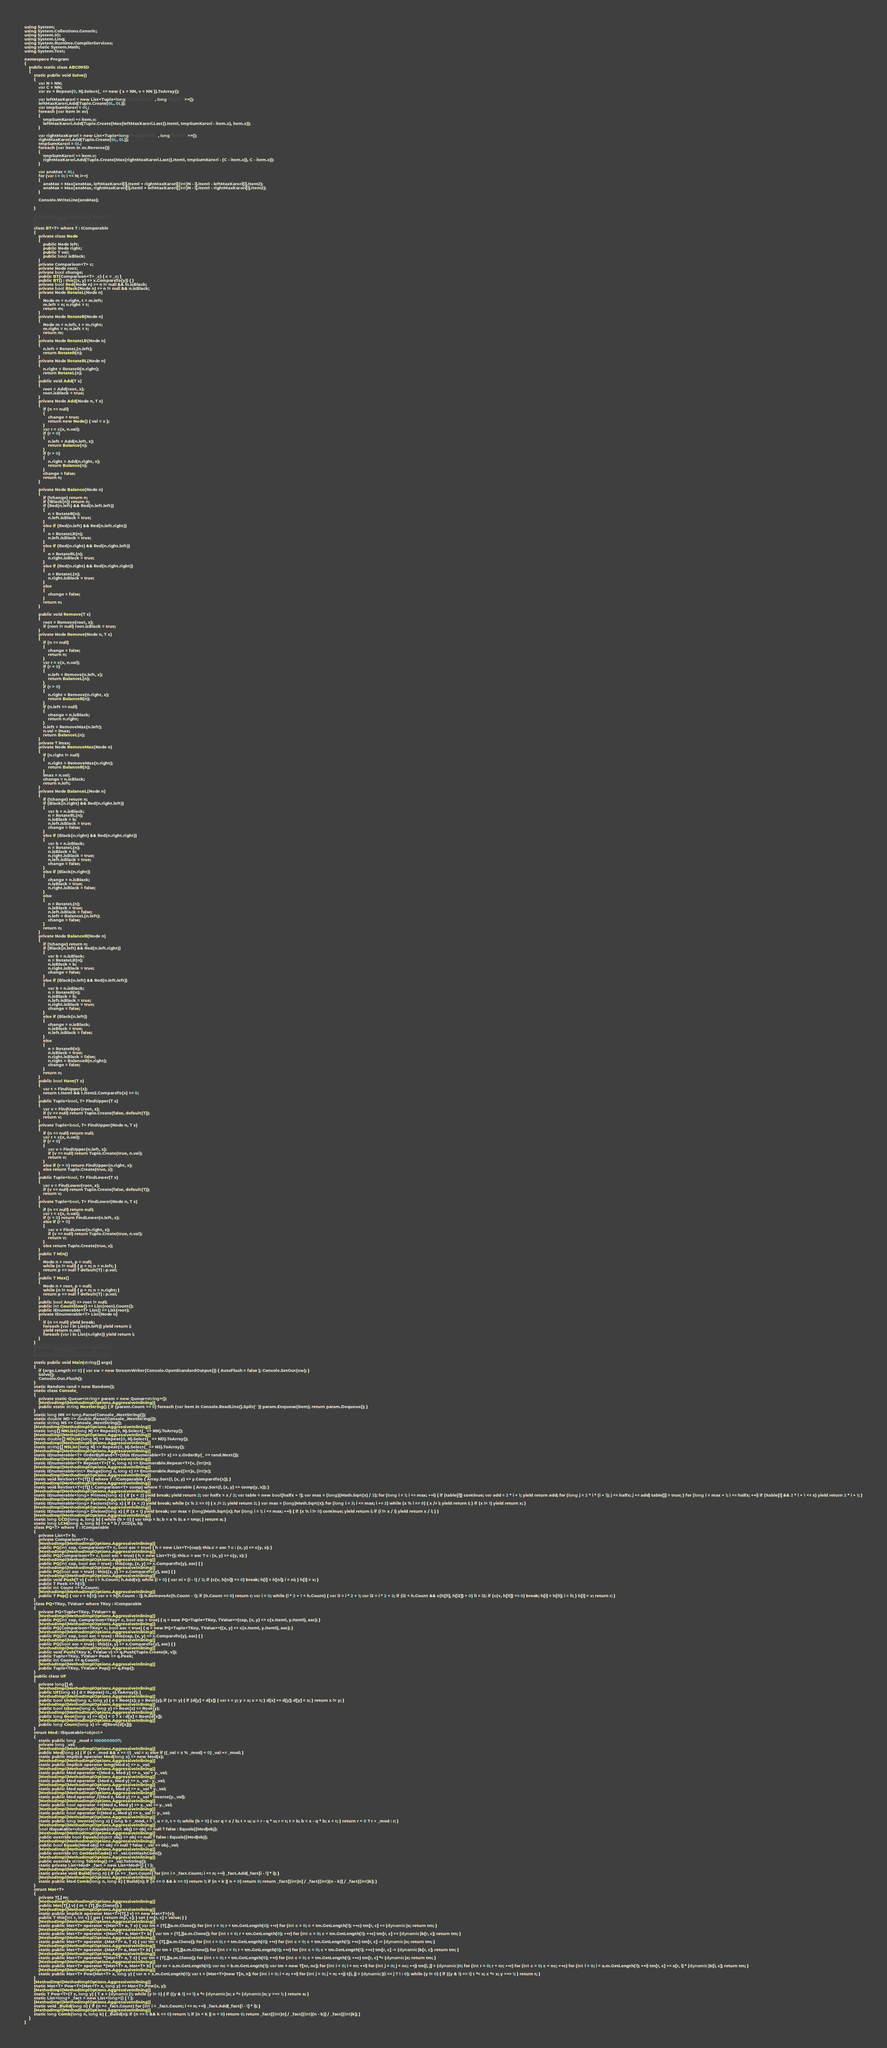Convert code to text. <code><loc_0><loc_0><loc_500><loc_500><_C#_>using System;
using System.Collections.Generic;
using System.IO;
using System.Linq;
using System.Runtime.CompilerServices;
using static System.Math;
using System.Text;

namespace Program
{
    public static class ABC095D
    {
        static public void Solve()
        {
            var N = NN;
            var C = NN;
            var xv = Repeat(0, N).Select(_ => new { x = NN, v = NN }).ToArray();

            var leftMaxKarori = new List<Tuple<long/*maxkarori*/, long/*kyori*/>>();
            leftMaxKarori.Add(Tuple.Create(0L, 0L));
            var tmpSumKarori = 0L;
            foreach (var item in xv)
            {
                tmpSumKarori += item.v;
                leftMaxKarori.Add(Tuple.Create(Max(leftMaxKarori.Last().Item1, tmpSumKarori - item.x), item.x));
            }

            var rightMaxKarori = new List<Tuple<long/*maxkarori*/, long/*kyori*/>>();
            rightMaxKarori.Add(Tuple.Create(0L, 0L));
            tmpSumKarori = 0L;
            foreach (var item in xv.Reverse())
            {
                tmpSumKarori += item.v;
                rightMaxKarori.Add(Tuple.Create(Max(rightMaxKarori.Last().Item1, tmpSumKarori - (C - item.x)), C - item.x));
            }

            var ansMax = 0L;
            for (var i = 0; i <= N; i++)
            {
                ansMax = Max(ansMax, leftMaxKarori[i].Item1 + rightMaxKarori[(int)N - i].Item1 - leftMaxKarori[i].Item2);
                ansMax = Max(ansMax, rightMaxKarori[i].Item1 + leftMaxKarori[(int)N - i].Item1 - rightMaxKarori[i].Item2);
            }

            Console.WriteLine(ansMax);

        }

        //_/_/_/_/_/_/_/_/_/_/_/_/_/_/_/_/_/_/_/_/_/_/_/
        //                    TEST                    _/
        //_/_/_/_/_/_/_/_/_/_/_/_/_/_/_/_/_/_/_/_/_/_/_/
        class BT<T> where T : IComparable
        {
            private class Node
            {
                public Node left;
                public Node right;
                public T val;
                public bool isBlack;
            }
            private Comparison<T> c;
            private Node root;
            private bool change;
            public BT(Comparison<T> _c) { c = _c; }
            public BT() : this((x, y) => x.CompareTo(y)) { }
            private bool Red(Node n) => n != null && !n.isBlack;
            private bool Black(Node n) => n != null && n.isBlack;
            private Node RotateL(Node n)
            {
                Node m = n.right, t = m.left;
                m.left = n; n.right = t;
                return m;
            }
            private Node RotateR(Node n)
            {
                Node m = n.left, t = m.right;
                m.right = n; n.left = t;
                return m;
            }
            private Node RotateLR(Node n)
            {
                n.left = RotateL(n.left);
                return RotateR(n);
            }
            private Node RotateRL(Node n)
            {
                n.right = RotateR(n.right);
                return RotateL(n);
            }
            public void Add(T x)
            {
                root = Add(root, x);
                root.isBlack = true;
            }
            private Node Add(Node n, T x)
            {
                if (n == null)
                {
                    change = true;
                    return new Node() { val = x };
                }
                var r = c(x, n.val);
                if (r < 0)
                {
                    n.left = Add(n.left, x);
                    return Balance(n);
                }
                if (r > 0)
                {
                    n.right = Add(n.right, x);
                    return Balance(n);
                }
                change = false;
                return n;
            }

            private Node Balance(Node n)
            {
                if (!change) return n;
                if (!Black(n)) return n;
                if (Red(n.left) && Red(n.left.left))
                {
                    n = RotateR(n);
                    n.left.isBlack = true;
                }
                else if (Red(n.left) && Red(n.left.right))
                {
                    n = RotateLR(n);
                    n.left.isBlack = true;
                }
                else if (Red(n.right) && Red(n.right.left))
                {
                    n = RotateRL(n);
                    n.right.isBlack = true;
                }
                else if (Red(n.right) && Red(n.right.right))
                {
                    n = RotateL(n);
                    n.right.isBlack = true;
                }
                else
                {
                    change = false;
                }
                return n;
            }

            public void Remove(T x)
            {
                root = Remove(root, x);
                if (root != null) root.isBlack = true;
            }
            private Node Remove(Node n, T x)
            {
                if (n == null)
                {
                    change = false;
                    return n;
                }
                var r = c(x, n.val);
                if (r < 0)
                {
                    n.left = Remove(n.left, x);
                    return BalanceL(n);
                }
                if (r > 0)
                {
                    n.right = Remove(n.right, x);
                    return BalanceR(n);
                }
                if (n.left == null)
                {
                    change = n.isBlack;
                    return n.right;
                }
                n.left = RemoveMax(n.left);
                n.val = lmax;
                return BalanceL(n);
            }
            private T lmax;
            private Node RemoveMax(Node n)
            {
                if (n.right != null)
                {
                    n.right = RemoveMax(n.right);
                    return BalanceR(n);
                }
                lmax = n.val;
                change = n.isBlack;
                return n.left;
            }
            private Node BalanceL(Node n)
            {
                if (!change) return n;
                if (Black(n.right) && Red(n.right.left))
                {
                    var b = n.isBlack;
                    n = RotateRL(n);
                    n.isBlack = b;
                    n.left.isBlack = true;
                    change = false;
                }
                else if (Black(n.right) && Red(n.right.right))
                {
                    var b = n.isBlack;
                    n = RotateL(n);
                    n.isBlack = b;
                    n.right.isBlack = true;
                    n.left.isBlack = true;
                    change = false;
                }
                else if (Black(n.right))
                {
                    change = n.isBlack;
                    n.isBlack = true;
                    n.right.isBlack = false;
                }
                else
                {
                    n = RotateL(n);
                    n.isBlack = true;
                    n.left.isBlack = false;
                    n.left = BalanceL(n.left);
                    change = false;
                }
                return n;
            }
            private Node BalanceR(Node n)
            {
                if (!change) return n;
                if (Black(n.left) && Red(n.left.right))
                {
                    var b = n.isBlack;
                    n = RotateLR(n);
                    n.isBlack = b;
                    n.right.isBlack = true;
                    change = false;
                }
                else if (Black(n.left) && Red(n.left.left))
                {
                    var b = n.isBlack;
                    n = RotateR(n);
                    n.isBlack = b;
                    n.left.isBlack = true;
                    n.right.isBlack = true;
                    change = false;
                }
                else if (Black(n.left))
                {
                    change = n.isBlack;
                    n.isBlack = true;
                    n.left.isBlack = false;
                }
                else
                {
                    n = RotateR(n);
                    n.isBlack = true;
                    n.right.isBlack = false;
                    n.right = BalanceR(n.right);
                    change = false;
                }
                return n;
            }
            public bool Have(T x)
            {
                var t = FindUpper(x);
                return t.Item1 && t.Item2.CompareTo(x) == 0;
            }
            public Tuple<bool, T> FindUpper(T x)
            {
                var v = FindUpper(root, x);
                if (v == null) return Tuple.Create(false, default(T));
                return v;
            }
            private Tuple<bool, T> FindUpper(Node n, T x)
            {
                if (n == null) return null;
                var r = c(x, n.val);
                if (r < 0)
                {
                    var v = FindUpper(n.left, x);
                    if (v == null) return Tuple.Create(true, n.val);
                    return v;
                }
                else if (r > 0) return FindUpper(n.right, x);
                else return Tuple.Create(true, x);
            }
            public Tuple<bool, T> FindLower(T x)
            {
                var v = FindLower(root, x);
                if (v == null) return Tuple.Create(false, default(T));
                return v;
            }
            private Tuple<bool, T> FindLower(Node n, T x)
            {
                if (n == null) return null;
                var r = c(x, n.val);
                if (r < 0) return FindLower(n.left, x);
                else if (r > 0)
                {
                    var v = FindLower(n.right, x);
                    if (v == null) return Tuple.Create(true, n.val);
                    return v;
                }
                else return Tuple.Create(true, x);
            }
            public T Min()
            {
                Node n = root, p = null;
                while (n != null) { p = n; n = n.left; }
                return p == null ? default(T) : p.val;
            }
            public T Max()
            {
                Node n = root, p = null;
                while (n != null) { p = n; n = n.right; }
                return p == null ? default(T) : p.val;
            }
            public bool Any() => root != null;
            public int CountSlow() => List(root).Count();
            public IEnumerable<T> List() => List(root);
            private IEnumerable<T> List(Node n)
            {
                if (n == null) yield break;
                foreach (var i in List(n.left)) yield return i;
                yield return n.val;
                foreach (var i in List(n.right)) yield return i;
            }
        }
        //_/_/_/_/_/_/_/_/_/_/_/_/_/_/_/_/_/_/_/_/_/_/_/
        //                  TEST END                  _/
        //_/_/_/_/_/_/_/_/_/_/_/_/_/_/_/_/_/_/_/_/_/_/_/

        static public void Main(string[] args)
        {
            if (args.Length == 0) { var sw = new StreamWriter(Console.OpenStandardOutput()) { AutoFlush = false }; Console.SetOut(sw); }
            Solve();
            Console.Out.Flush();
        }
        static Random rand = new Random();
        static class Console_
        {
            private static Queue<string> param = new Queue<string>();
            [MethodImpl(MethodImplOptions.AggressiveInlining)]
            public static string NextString() { if (param.Count == 0) foreach (var item in Console.ReadLine().Split(' ')) param.Enqueue(item); return param.Dequeue(); }
        }
        static long NN => long.Parse(Console_.NextString());
        static double ND => double.Parse(Console_.NextString());
        static string NS => Console_.NextString();
        [MethodImpl(MethodImplOptions.AggressiveInlining)]
        static long[] NNList(long N) => Repeat(0, N).Select(_ => NN).ToArray();
        [MethodImpl(MethodImplOptions.AggressiveInlining)]
        static double[] NDList(long N) => Repeat(0, N).Select(_ => ND).ToArray();
        [MethodImpl(MethodImplOptions.AggressiveInlining)]
        static string[] NSList(long N) => Repeat(0, N).Select(_ => NS).ToArray();
        [MethodImpl(MethodImplOptions.AggressiveInlining)]
        static IEnumerable<T> OrderByRand<T>(this IEnumerable<T> x) => x.OrderBy(_ => rand.Next());
        [MethodImpl(MethodImplOptions.AggressiveInlining)]
        static IEnumerable<T> Repeat<T>(T v, long n) => Enumerable.Repeat<T>(v, (int)n);
        [MethodImpl(MethodImplOptions.AggressiveInlining)]
        static IEnumerable<int> Range(long s, long c) => Enumerable.Range((int)s, (int)c);
        [MethodImpl(MethodImplOptions.AggressiveInlining)]
        static void RevSort<T>(T[] l) where T : IComparable { Array.Sort(l, (x, y) => y.CompareTo(x)); }
        [MethodImpl(MethodImplOptions.AggressiveInlining)]
        static void RevSort<T>(T[] l, Comparison<T> comp) where T : IComparable { Array.Sort(l, (x, y) => comp(y, x)); }
        [MethodImpl(MethodImplOptions.AggressiveInlining)]
        static IEnumerable<long> Primes(long x) { if (x < 2) yield break; yield return 2; var halfx = x / 2; var table = new bool[halfx + 1]; var max = (long)(Math.Sqrt(x) / 2); for (long i = 1; i <= max; ++i) { if (table[i]) continue; var add = 2 * i + 1; yield return add; for (long j = 2 * i * (i + 1); j <= halfx; j += add) table[j] = true; } for (long i = max + 1; i <= halfx; ++i) if (!table[i] && 2 * i + 1 <= x) yield return 2 * i + 1; }
        [MethodImpl(MethodImplOptions.AggressiveInlining)]
        static IEnumerable<long> Factors(long x) { if (x < 2) yield break; while (x % 2 == 0) { x /= 2; yield return 2; } var max = (long)Math.Sqrt(x); for (long i = 3; i <= max; i += 2) while (x % i == 0) { x /= i; yield return i; } if (x != 1) yield return x; }
        [MethodImpl(MethodImplOptions.AggressiveInlining)]
        static IEnumerable<long> Divisor(long x) { if (x < 1) yield break; var max = (long)Math.Sqrt(x); for (long i = 1; i <= max; ++i) { if (x % i != 0) continue; yield return i; if (i != x / i) yield return x / i; } }
        [MethodImpl(MethodImplOptions.AggressiveInlining)]
        static long GCD(long a, long b) { while (b > 0) { var tmp = b; b = a % b; a = tmp; } return a; }
        static long LCM(long a, long b) => a * b / GCD(a, b);
        class PQ<T> where T : IComparable
        {
            private List<T> h;
            private Comparison<T> c;
            [MethodImpl(MethodImplOptions.AggressiveInlining)]
            public PQ(int cap, Comparison<T> c, bool asc = true) { h = new List<T>(cap); this.c = asc ? c : (x, y) => c(y, x); }
            [MethodImpl(MethodImplOptions.AggressiveInlining)]
            public PQ(Comparison<T> c, bool asc = true) { h = new List<T>(); this.c = asc ? c : (x, y) => c(y, x); }
            [MethodImpl(MethodImplOptions.AggressiveInlining)]
            public PQ(int cap, bool asc = true) : this(cap, (x, y) => x.CompareTo(y), asc) { }
            [MethodImpl(MethodImplOptions.AggressiveInlining)]
            public PQ(bool asc = true) : this((x, y) => x.CompareTo(y), asc) { }
            [MethodImpl(MethodImplOptions.AggressiveInlining)]
            public void Push(T v) { var i = h.Count; h.Add(v); while (i > 0) { var ni = (i - 1) / 2; if (c(v, h[ni]) >= 0) break; h[i] = h[ni]; i = ni; } h[i] = v; }
            public T Peek => h[0];
            public int Count => h.Count;
            [MethodImpl(MethodImplOptions.AggressiveInlining)]
            public T Pop() { var r = h[0]; var v = h[h.Count - 1]; h.RemoveAt(h.Count - 1); if (h.Count == 0) return r; var i = 0; while (i * 2 + 1 < h.Count) { var i1 = i * 2 + 1; var i2 = i * 2 + 2; if (i2 < h.Count && c(h[i1], h[i2]) > 0) i1 = i2; if (c(v, h[i1]) <= 0) break; h[i] = h[i1]; i = i1; } h[i] = v; return r; }
        }
        class PQ<TKey, TValue> where TKey : IComparable
        {
            private PQ<Tuple<TKey, TValue>> q;
            [MethodImpl(MethodImplOptions.AggressiveInlining)]
            public PQ(int cap, Comparison<TKey> c, bool asc = true) { q = new PQ<Tuple<TKey, TValue>>(cap, (x, y) => c(x.Item1, y.Item1), asc); }
            [MethodImpl(MethodImplOptions.AggressiveInlining)]
            public PQ(Comparison<TKey> c, bool asc = true) { q = new PQ<Tuple<TKey, TValue>>((x, y) => c(x.Item1, y.Item1), asc); }
            [MethodImpl(MethodImplOptions.AggressiveInlining)]
            public PQ(int cap, bool asc = true) : this(cap, (x, y) => x.CompareTo(y), asc) { }
            [MethodImpl(MethodImplOptions.AggressiveInlining)]
            public PQ(bool asc = true) : this((x, y) => x.CompareTo(y), asc) { }
            [MethodImpl(MethodImplOptions.AggressiveInlining)]
            public void Push(TKey k, TValue v) => q.Push(Tuple.Create(k, v));
            public Tuple<TKey, TValue> Peek => q.Peek;
            public int Count => q.Count;
            [MethodImpl(MethodImplOptions.AggressiveInlining)]
            public Tuple<TKey, TValue> Pop() => q.Pop();
        }
        public class UF
        {
            private long[] d;
            [MethodImpl(MethodImplOptions.AggressiveInlining)]
            public UF(long s) { d = Repeat(-1L, s).ToArray(); }
            [MethodImpl(MethodImplOptions.AggressiveInlining)]
            public bool Unite(long x, long y) { x = Root(x); y = Root(y); if (x != y) { if (d[y] < d[x]) { var t = y; y = x; x = t; } d[x] += d[y]; d[y] = x; } return x != y; }
            [MethodImpl(MethodImplOptions.AggressiveInlining)]
            public bool IsSame(long x, long y) => Root(x) == Root(y);
            [MethodImpl(MethodImplOptions.AggressiveInlining)]
            public long Root(long x) => d[x] < 0 ? x : d[x] = Root(d[x]);
            [MethodImpl(MethodImplOptions.AggressiveInlining)]
            public long Count(long x) => -d[Root(d[x])];
        }
        struct Mod : IEquatable<object>
        {
            static public long _mod = 1000000007;
            private long _val;
            [MethodImpl(MethodImplOptions.AggressiveInlining)]
            public Mod(long x) { if (x < _mod && x >= 0) _val = x; else if ((_val = x % _mod) < 0) _val += _mod; }
            static public implicit operator Mod(long x) => new Mod(x);
            [MethodImpl(MethodImplOptions.AggressiveInlining)]
            static public implicit operator long(Mod x) => x._val;
            [MethodImpl(MethodImplOptions.AggressiveInlining)]
            static public Mod operator +(Mod x, Mod y) => x._val + y._val;
            [MethodImpl(MethodImplOptions.AggressiveInlining)]
            static public Mod operator -(Mod x, Mod y) => x._val - y._val;
            [MethodImpl(MethodImplOptions.AggressiveInlining)]
            static public Mod operator *(Mod x, Mod y) => x._val * y._val;
            [MethodImpl(MethodImplOptions.AggressiveInlining)]
            static public Mod operator /(Mod x, Mod y) => x._val * Inverse(y._val);
            [MethodImpl(MethodImplOptions.AggressiveInlining)]
            static public bool operator ==(Mod x, Mod y) => x._val == y._val;
            [MethodImpl(MethodImplOptions.AggressiveInlining)]
            static public bool operator !=(Mod x, Mod y) => x._val != y._val;
            [MethodImpl(MethodImplOptions.AggressiveInlining)]
            static public long Inverse(long x) { long b = _mod, r = 1, u = 0, t = 0; while (b > 0) { var q = x / b; t = u; u = r - q * u; r = t; t = b; b = x - q * b; x = t; } return r < 0 ? r + _mod : r; }
            [MethodImpl(MethodImplOptions.AggressiveInlining)]
            bool IEquatable<object>.Equals(object obj) => obj == null ? false : Equals((Mod)obj);
            [MethodImpl(MethodImplOptions.AggressiveInlining)]
            public override bool Equals(object obj) => obj == null ? false : Equals((Mod)obj);
            [MethodImpl(MethodImplOptions.AggressiveInlining)]
            public bool Equals(Mod obj) => obj == null ? false : _val == obj._val;
            [MethodImpl(MethodImplOptions.AggressiveInlining)]
            public override int GetHashCode() => _val.GetHashCode();
            [MethodImpl(MethodImplOptions.AggressiveInlining)]
            public override string ToString() => _val.ToString();
            static private List<Mod> _fact = new List<Mod>() { 1 };
            [MethodImpl(MethodImplOptions.AggressiveInlining)]
            static private void Build(long n) { if (n >= _fact.Count) for (int i = _fact.Count; i <= n; ++i) _fact.Add(_fact[i - 1] * i); }
            [MethodImpl(MethodImplOptions.AggressiveInlining)]
            static public Mod Comb(long n, long k) { Build(n); if (n == 0 && k == 0) return 1; if (n < k || n < 0) return 0; return _fact[(int)n] / _fact[(int)(n - k)] / _fact[(int)k]; }
        }
        struct Mat<T>
        {
            private T[,] m;
            [MethodImpl(MethodImplOptions.AggressiveInlining)]
            public Mat(T[,] v) { m = (T[,])v.Clone(); }
            [MethodImpl(MethodImplOptions.AggressiveInlining)]
            static public implicit operator Mat<T>(T[,] v) => new Mat<T>(v);
            public T this[int r, int c] { get { return m[r, c]; } set { m[r, c] = value; } }
            [MethodImpl(MethodImplOptions.AggressiveInlining)]
            static public Mat<T> operator +(Mat<T> a, T x) { var tm = (T[,])a.m.Clone(); for (int r = 0; r < tm.GetLength(0); ++r) for (int c = 0; c < tm.GetLength(1); ++c) tm[r, c] += (dynamic)x; return tm; }
            [MethodImpl(MethodImplOptions.AggressiveInlining)]
            static public Mat<T> operator +(Mat<T> a, Mat<T> b) { var tm = (T[,])a.m.Clone(); for (int r = 0; r < tm.GetLength(0); ++r) for (int c = 0; c < tm.GetLength(1); ++c) tm[r, c] += (dynamic)b[r, c]; return tm; }
            [MethodImpl(MethodImplOptions.AggressiveInlining)]
            static public Mat<T> operator -(Mat<T> a, T x) { var tm = (T[,])a.m.Clone(); for (int r = 0; r < tm.GetLength(0); ++r) for (int c = 0; c < tm.GetLength(1); ++c) tm[r, c] -= (dynamic)x; return tm; }
            [MethodImpl(MethodImplOptions.AggressiveInlining)]
            static public Mat<T> operator -(Mat<T> a, Mat<T> b) { var tm = (T[,])a.m.Clone(); for (int r = 0; r < tm.GetLength(0); ++r) for (int c = 0; c < tm.GetLength(1); ++c) tm[r, c] -= (dynamic)b[r, c]; return tm; }
            [MethodImpl(MethodImplOptions.AggressiveInlining)]
            static public Mat<T> operator *(Mat<T> a, T x) { var tm = (T[,])a.m.Clone(); for (int r = 0; r < tm.GetLength(0); ++r) for (int c = 0; c < tm.GetLength(1); ++c) tm[r, c] *= (dynamic)x; return tm; }
            [MethodImpl(MethodImplOptions.AggressiveInlining)]
            static public Mat<T> operator *(Mat<T> a, Mat<T> b) { var nr = a.m.GetLength(0); var nc = b.m.GetLength(1); var tm = new T[nr, nc]; for (int i = 0; i < nr; ++i) for (int j = 0; j < nc; ++j) tm[i, j] = (dynamic)0; for (int r = 0; r < nr; ++r) for (int c = 0; c < nc; ++c) for (int i = 0; i < a.m.GetLength(1); ++i) tm[r, c] += a[r, i] * (dynamic)b[i, c]; return tm; }
            [MethodImpl(MethodImplOptions.AggressiveInlining)]
            static public Mat<T> Pow(Mat<T> x, long y) { var n = x.m.GetLength(0); var t = (Mat<T>)new T[n, n]; for (int i = 0; i < n; ++i) for (int j = 0; j < n; ++j) t[i, j] = (dynamic)(i == j ? 1 : 0); while (y != 0) { if ((y & 1) == 1) t *= x; x *= x; y >>= 1; } return t; }
        }
        [MethodImpl(MethodImplOptions.AggressiveInlining)]
        static Mat<T> Pow<T>(Mat<T> x, long y) => Mat<T>.Pow(x, y);
        [MethodImpl(MethodImplOptions.AggressiveInlining)]
        static T Pow<T>(T x, long y) { T a = (dynamic)1; while (y != 0) { if ((y & 1) == 1) a *= (dynamic)x; x *= (dynamic)x; y >>= 1; } return a; }
        static List<long> _fact = new List<long>() { 1 };
        [MethodImpl(MethodImplOptions.AggressiveInlining)]
        static void _Build(long n) { if (n >= _fact.Count) for (int i = _fact.Count; i <= n; ++i) _fact.Add(_fact[i - 1] * i); }
        [MethodImpl(MethodImplOptions.AggressiveInlining)]
        static long Comb(long n, long k) { _Build(n); if (n == 0 && k == 0) return 1; if (n < k || n < 0) return 0; return _fact[(int)n] / _fact[(int)(n - k)] / _fact[(int)k]; }
    }
}
</code> 